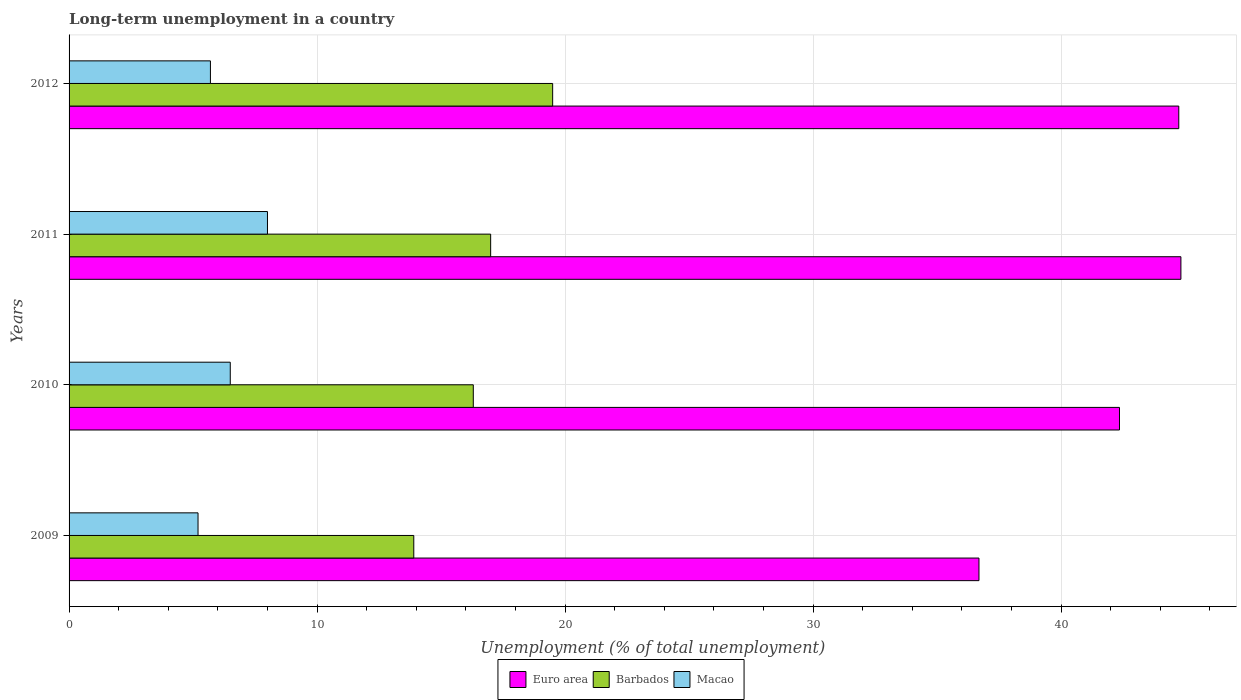How many different coloured bars are there?
Offer a terse response. 3. How many bars are there on the 2nd tick from the bottom?
Your answer should be very brief. 3. What is the label of the 3rd group of bars from the top?
Keep it short and to the point. 2010. What is the percentage of long-term unemployed population in Macao in 2012?
Give a very brief answer. 5.7. Across all years, what is the minimum percentage of long-term unemployed population in Barbados?
Your answer should be very brief. 13.9. What is the total percentage of long-term unemployed population in Macao in the graph?
Ensure brevity in your answer.  25.4. What is the difference between the percentage of long-term unemployed population in Macao in 2009 and that in 2010?
Give a very brief answer. -1.3. What is the average percentage of long-term unemployed population in Euro area per year?
Your answer should be compact. 42.16. In the year 2009, what is the difference between the percentage of long-term unemployed population in Macao and percentage of long-term unemployed population in Barbados?
Make the answer very short. -8.7. In how many years, is the percentage of long-term unemployed population in Macao greater than 42 %?
Your answer should be very brief. 0. What is the ratio of the percentage of long-term unemployed population in Macao in 2009 to that in 2011?
Provide a short and direct response. 0.65. What is the difference between the highest and the second highest percentage of long-term unemployed population in Barbados?
Offer a very short reply. 2.5. What is the difference between the highest and the lowest percentage of long-term unemployed population in Barbados?
Offer a terse response. 5.6. In how many years, is the percentage of long-term unemployed population in Euro area greater than the average percentage of long-term unemployed population in Euro area taken over all years?
Offer a terse response. 3. Is the sum of the percentage of long-term unemployed population in Macao in 2011 and 2012 greater than the maximum percentage of long-term unemployed population in Barbados across all years?
Offer a very short reply. No. What does the 2nd bar from the bottom in 2009 represents?
Your answer should be very brief. Barbados. Is it the case that in every year, the sum of the percentage of long-term unemployed population in Euro area and percentage of long-term unemployed population in Barbados is greater than the percentage of long-term unemployed population in Macao?
Provide a short and direct response. Yes. Are all the bars in the graph horizontal?
Give a very brief answer. Yes. What is the difference between two consecutive major ticks on the X-axis?
Your answer should be compact. 10. Are the values on the major ticks of X-axis written in scientific E-notation?
Offer a very short reply. No. Where does the legend appear in the graph?
Keep it short and to the point. Bottom center. What is the title of the graph?
Make the answer very short. Long-term unemployment in a country. What is the label or title of the X-axis?
Offer a terse response. Unemployment (% of total unemployment). What is the label or title of the Y-axis?
Offer a very short reply. Years. What is the Unemployment (% of total unemployment) in Euro area in 2009?
Make the answer very short. 36.69. What is the Unemployment (% of total unemployment) in Barbados in 2009?
Provide a short and direct response. 13.9. What is the Unemployment (% of total unemployment) of Macao in 2009?
Your response must be concise. 5.2. What is the Unemployment (% of total unemployment) in Euro area in 2010?
Make the answer very short. 42.36. What is the Unemployment (% of total unemployment) of Barbados in 2010?
Keep it short and to the point. 16.3. What is the Unemployment (% of total unemployment) of Macao in 2010?
Your answer should be compact. 6.5. What is the Unemployment (% of total unemployment) in Euro area in 2011?
Your answer should be compact. 44.83. What is the Unemployment (% of total unemployment) in Barbados in 2011?
Your answer should be compact. 17. What is the Unemployment (% of total unemployment) in Euro area in 2012?
Provide a short and direct response. 44.75. What is the Unemployment (% of total unemployment) in Macao in 2012?
Make the answer very short. 5.7. Across all years, what is the maximum Unemployment (% of total unemployment) of Euro area?
Your answer should be very brief. 44.83. Across all years, what is the minimum Unemployment (% of total unemployment) of Euro area?
Keep it short and to the point. 36.69. Across all years, what is the minimum Unemployment (% of total unemployment) of Barbados?
Provide a short and direct response. 13.9. Across all years, what is the minimum Unemployment (% of total unemployment) of Macao?
Provide a short and direct response. 5.2. What is the total Unemployment (% of total unemployment) in Euro area in the graph?
Ensure brevity in your answer.  168.63. What is the total Unemployment (% of total unemployment) in Barbados in the graph?
Provide a short and direct response. 66.7. What is the total Unemployment (% of total unemployment) of Macao in the graph?
Ensure brevity in your answer.  25.4. What is the difference between the Unemployment (% of total unemployment) in Euro area in 2009 and that in 2010?
Offer a very short reply. -5.67. What is the difference between the Unemployment (% of total unemployment) in Barbados in 2009 and that in 2010?
Provide a succinct answer. -2.4. What is the difference between the Unemployment (% of total unemployment) in Macao in 2009 and that in 2010?
Provide a short and direct response. -1.3. What is the difference between the Unemployment (% of total unemployment) of Euro area in 2009 and that in 2011?
Offer a very short reply. -8.14. What is the difference between the Unemployment (% of total unemployment) of Barbados in 2009 and that in 2011?
Give a very brief answer. -3.1. What is the difference between the Unemployment (% of total unemployment) of Macao in 2009 and that in 2011?
Your response must be concise. -2.8. What is the difference between the Unemployment (% of total unemployment) in Euro area in 2009 and that in 2012?
Your answer should be very brief. -8.06. What is the difference between the Unemployment (% of total unemployment) of Barbados in 2009 and that in 2012?
Provide a succinct answer. -5.6. What is the difference between the Unemployment (% of total unemployment) in Euro area in 2010 and that in 2011?
Your answer should be very brief. -2.48. What is the difference between the Unemployment (% of total unemployment) of Barbados in 2010 and that in 2011?
Your answer should be very brief. -0.7. What is the difference between the Unemployment (% of total unemployment) of Macao in 2010 and that in 2011?
Keep it short and to the point. -1.5. What is the difference between the Unemployment (% of total unemployment) in Euro area in 2010 and that in 2012?
Make the answer very short. -2.39. What is the difference between the Unemployment (% of total unemployment) in Barbados in 2010 and that in 2012?
Your response must be concise. -3.2. What is the difference between the Unemployment (% of total unemployment) in Macao in 2010 and that in 2012?
Your response must be concise. 0.8. What is the difference between the Unemployment (% of total unemployment) in Euro area in 2011 and that in 2012?
Offer a terse response. 0.09. What is the difference between the Unemployment (% of total unemployment) of Euro area in 2009 and the Unemployment (% of total unemployment) of Barbados in 2010?
Keep it short and to the point. 20.39. What is the difference between the Unemployment (% of total unemployment) in Euro area in 2009 and the Unemployment (% of total unemployment) in Macao in 2010?
Your answer should be compact. 30.19. What is the difference between the Unemployment (% of total unemployment) of Euro area in 2009 and the Unemployment (% of total unemployment) of Barbados in 2011?
Make the answer very short. 19.69. What is the difference between the Unemployment (% of total unemployment) of Euro area in 2009 and the Unemployment (% of total unemployment) of Macao in 2011?
Offer a very short reply. 28.69. What is the difference between the Unemployment (% of total unemployment) in Barbados in 2009 and the Unemployment (% of total unemployment) in Macao in 2011?
Provide a short and direct response. 5.9. What is the difference between the Unemployment (% of total unemployment) in Euro area in 2009 and the Unemployment (% of total unemployment) in Barbados in 2012?
Offer a very short reply. 17.19. What is the difference between the Unemployment (% of total unemployment) in Euro area in 2009 and the Unemployment (% of total unemployment) in Macao in 2012?
Make the answer very short. 30.99. What is the difference between the Unemployment (% of total unemployment) in Barbados in 2009 and the Unemployment (% of total unemployment) in Macao in 2012?
Provide a short and direct response. 8.2. What is the difference between the Unemployment (% of total unemployment) in Euro area in 2010 and the Unemployment (% of total unemployment) in Barbados in 2011?
Your response must be concise. 25.36. What is the difference between the Unemployment (% of total unemployment) of Euro area in 2010 and the Unemployment (% of total unemployment) of Macao in 2011?
Make the answer very short. 34.36. What is the difference between the Unemployment (% of total unemployment) of Barbados in 2010 and the Unemployment (% of total unemployment) of Macao in 2011?
Offer a very short reply. 8.3. What is the difference between the Unemployment (% of total unemployment) of Euro area in 2010 and the Unemployment (% of total unemployment) of Barbados in 2012?
Your answer should be very brief. 22.86. What is the difference between the Unemployment (% of total unemployment) in Euro area in 2010 and the Unemployment (% of total unemployment) in Macao in 2012?
Ensure brevity in your answer.  36.66. What is the difference between the Unemployment (% of total unemployment) in Euro area in 2011 and the Unemployment (% of total unemployment) in Barbados in 2012?
Offer a very short reply. 25.33. What is the difference between the Unemployment (% of total unemployment) in Euro area in 2011 and the Unemployment (% of total unemployment) in Macao in 2012?
Keep it short and to the point. 39.13. What is the difference between the Unemployment (% of total unemployment) in Barbados in 2011 and the Unemployment (% of total unemployment) in Macao in 2012?
Your answer should be very brief. 11.3. What is the average Unemployment (% of total unemployment) in Euro area per year?
Ensure brevity in your answer.  42.16. What is the average Unemployment (% of total unemployment) of Barbados per year?
Keep it short and to the point. 16.68. What is the average Unemployment (% of total unemployment) in Macao per year?
Ensure brevity in your answer.  6.35. In the year 2009, what is the difference between the Unemployment (% of total unemployment) in Euro area and Unemployment (% of total unemployment) in Barbados?
Provide a short and direct response. 22.79. In the year 2009, what is the difference between the Unemployment (% of total unemployment) of Euro area and Unemployment (% of total unemployment) of Macao?
Your response must be concise. 31.49. In the year 2010, what is the difference between the Unemployment (% of total unemployment) in Euro area and Unemployment (% of total unemployment) in Barbados?
Make the answer very short. 26.06. In the year 2010, what is the difference between the Unemployment (% of total unemployment) of Euro area and Unemployment (% of total unemployment) of Macao?
Make the answer very short. 35.86. In the year 2011, what is the difference between the Unemployment (% of total unemployment) in Euro area and Unemployment (% of total unemployment) in Barbados?
Ensure brevity in your answer.  27.83. In the year 2011, what is the difference between the Unemployment (% of total unemployment) in Euro area and Unemployment (% of total unemployment) in Macao?
Offer a very short reply. 36.83. In the year 2011, what is the difference between the Unemployment (% of total unemployment) of Barbados and Unemployment (% of total unemployment) of Macao?
Your response must be concise. 9. In the year 2012, what is the difference between the Unemployment (% of total unemployment) in Euro area and Unemployment (% of total unemployment) in Barbados?
Offer a terse response. 25.25. In the year 2012, what is the difference between the Unemployment (% of total unemployment) in Euro area and Unemployment (% of total unemployment) in Macao?
Offer a very short reply. 39.05. What is the ratio of the Unemployment (% of total unemployment) in Euro area in 2009 to that in 2010?
Your answer should be compact. 0.87. What is the ratio of the Unemployment (% of total unemployment) of Barbados in 2009 to that in 2010?
Ensure brevity in your answer.  0.85. What is the ratio of the Unemployment (% of total unemployment) in Macao in 2009 to that in 2010?
Ensure brevity in your answer.  0.8. What is the ratio of the Unemployment (% of total unemployment) of Euro area in 2009 to that in 2011?
Your answer should be compact. 0.82. What is the ratio of the Unemployment (% of total unemployment) in Barbados in 2009 to that in 2011?
Your answer should be very brief. 0.82. What is the ratio of the Unemployment (% of total unemployment) in Macao in 2009 to that in 2011?
Your answer should be compact. 0.65. What is the ratio of the Unemployment (% of total unemployment) of Euro area in 2009 to that in 2012?
Your answer should be very brief. 0.82. What is the ratio of the Unemployment (% of total unemployment) of Barbados in 2009 to that in 2012?
Your answer should be compact. 0.71. What is the ratio of the Unemployment (% of total unemployment) of Macao in 2009 to that in 2012?
Your answer should be very brief. 0.91. What is the ratio of the Unemployment (% of total unemployment) in Euro area in 2010 to that in 2011?
Your answer should be very brief. 0.94. What is the ratio of the Unemployment (% of total unemployment) of Barbados in 2010 to that in 2011?
Ensure brevity in your answer.  0.96. What is the ratio of the Unemployment (% of total unemployment) in Macao in 2010 to that in 2011?
Ensure brevity in your answer.  0.81. What is the ratio of the Unemployment (% of total unemployment) in Euro area in 2010 to that in 2012?
Give a very brief answer. 0.95. What is the ratio of the Unemployment (% of total unemployment) of Barbados in 2010 to that in 2012?
Offer a very short reply. 0.84. What is the ratio of the Unemployment (% of total unemployment) of Macao in 2010 to that in 2012?
Your answer should be compact. 1.14. What is the ratio of the Unemployment (% of total unemployment) in Barbados in 2011 to that in 2012?
Provide a succinct answer. 0.87. What is the ratio of the Unemployment (% of total unemployment) in Macao in 2011 to that in 2012?
Your response must be concise. 1.4. What is the difference between the highest and the second highest Unemployment (% of total unemployment) in Euro area?
Your answer should be compact. 0.09. What is the difference between the highest and the second highest Unemployment (% of total unemployment) in Barbados?
Offer a very short reply. 2.5. What is the difference between the highest and the lowest Unemployment (% of total unemployment) in Euro area?
Your response must be concise. 8.14. What is the difference between the highest and the lowest Unemployment (% of total unemployment) in Barbados?
Offer a terse response. 5.6. 